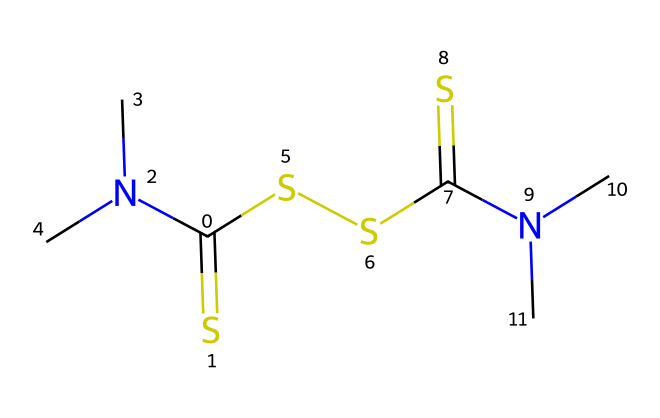What is the common name of this chemical? The SMILES representation shows the characteristic structure of thiram, which is a well-known dithiocarbamate fungicide used in agriculture.
Answer: thiram How many nitrogen atoms are present in this molecule? Analyzing the SMILES representation, there are two nitrogen atoms (shown by the "N" in both N(C)C groups).
Answer: two What type of bonds are present between C and N atoms in the molecule? The SMILES indicates the presence of direct single bonds (the structure suggests typical covalent bonding) between carbon (C) and nitrogen (N).
Answer: single bonds How many sulfur atoms are included in the molecular structure of thiram? The chemical structure displays four sulfur atoms, deduced from the "S" symbols in the SMILES, including two in the dithiocarbamate groups.
Answer: four What functional group characterizes thiram as a dithiocarbamate? The presence of the dithiocarbamate group is identified by the two "C(=S)" moieties (the carbon bonded to sulfur with a double bond), indicating its association with dithiocarbamate.
Answer: dithiocarbamate Which part of the molecule is primarily responsible for its fungicidal activity? The dithiocarbamate structure (C(=S)(N(C)C)S) interacts with the fungal enzyme systems, which inhibits their growth; thus, this specific arrangement is crucial for its efficacy.
Answer: dithiocarbamate What is the molecular formula derived from the SMILES representation? The SMILES contains a total of 8 carbons (C), 14 hydrogens (H), 2 nitrogens (N), and 4 sulfurs (S), leading to the molecular formula C8H14N2S4.
Answer: C8H14N2S4 